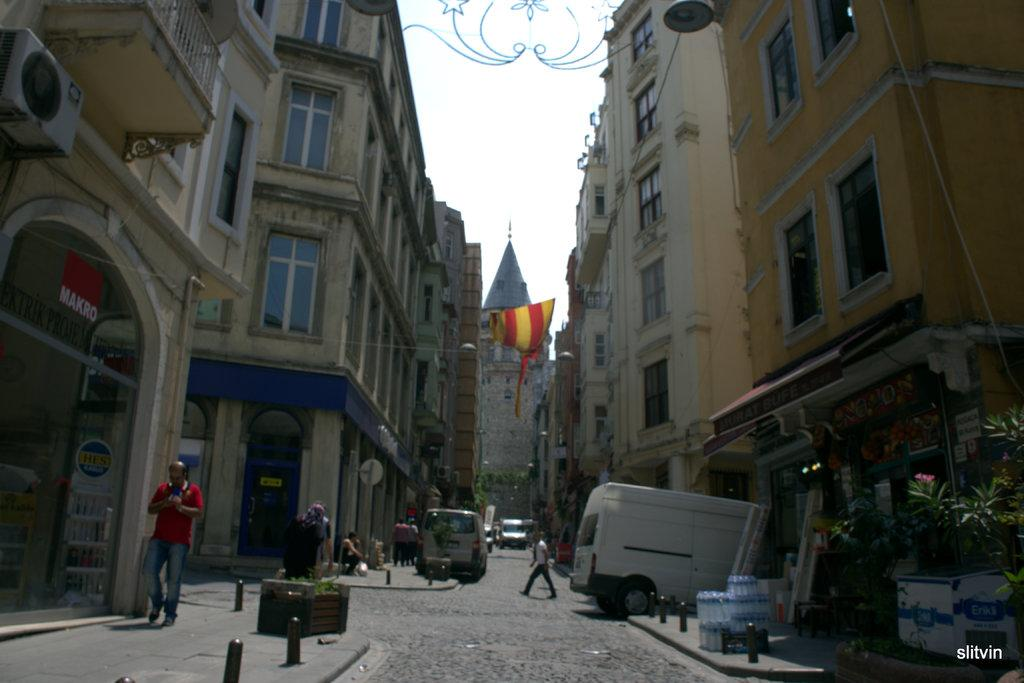What type of structures can be seen in the image? There are buildings in the image. Who or what else is present in the image? There are people and vehicles on the road in the image. What can be found on the right side of the image? There are plants and bottles on the right side of the image. What is visible in the background of the image? There is a flag and the sky in the background of the image. What type of glue is being used by the people in the image? There is no glue present in the image; people are not using any glue. Can you hear a whistle in the image? There is no whistle present in the image; it is a visual medium and does not convey sound. 